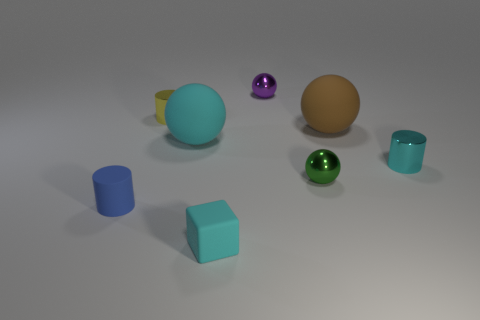Add 1 tiny green objects. How many objects exist? 9 Subtract all small green spheres. How many spheres are left? 3 Subtract all yellow cylinders. How many cylinders are left? 2 Add 8 cyan metal objects. How many cyan metal objects exist? 9 Subtract 0 green cylinders. How many objects are left? 8 Subtract all cylinders. How many objects are left? 5 Subtract 3 spheres. How many spheres are left? 1 Subtract all brown blocks. Subtract all gray cylinders. How many blocks are left? 1 Subtract all large cyan matte objects. Subtract all cyan matte cubes. How many objects are left? 6 Add 3 tiny cylinders. How many tiny cylinders are left? 6 